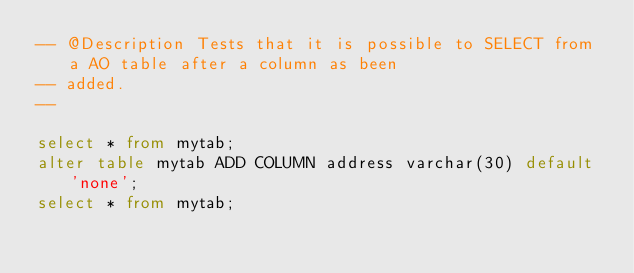Convert code to text. <code><loc_0><loc_0><loc_500><loc_500><_SQL_>-- @Description Tests that it is possible to SELECT from a AO table after a column as been
-- added.
-- 

select * from mytab;
alter table mytab ADD COLUMN address varchar(30) default 'none';
select * from mytab;
</code> 